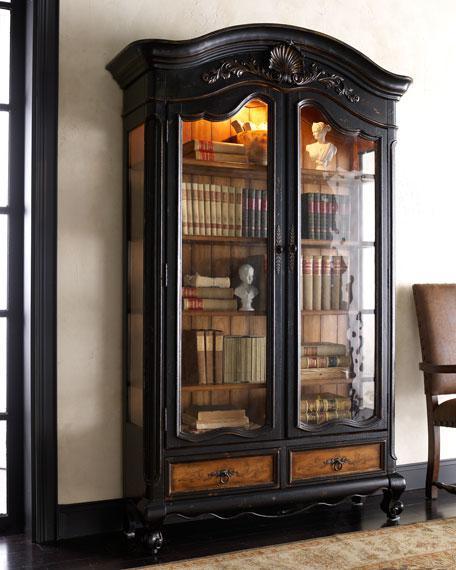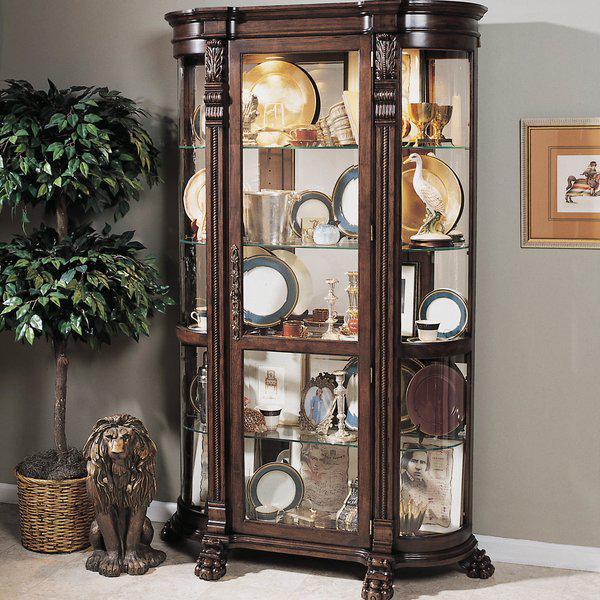The first image is the image on the left, the second image is the image on the right. Analyze the images presented: Is the assertion "The brown cabinet in the image on the right is storing images." valid? Answer yes or no. Yes. The first image is the image on the left, the second image is the image on the right. Analyze the images presented: Is the assertion "The cabinet in the right image has narrow legs and decorative curved top feature." valid? Answer yes or no. No. 